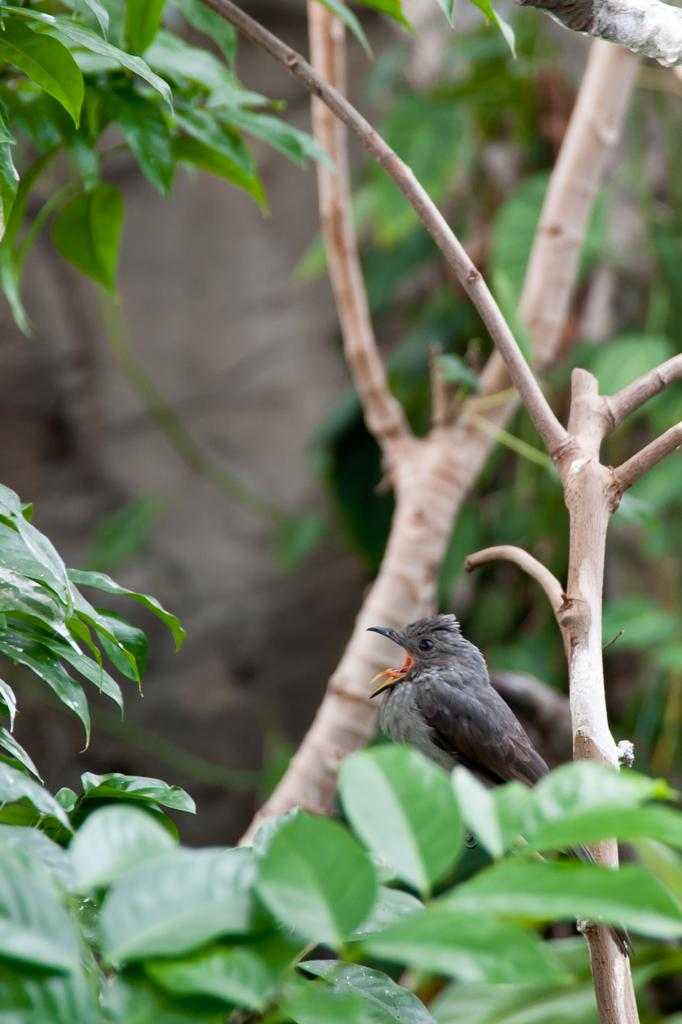What type of animal is in the image? There is a bird in the image. Where is the bird located? The bird is on a tree. Can you describe the background of the image? The background of the image is blurred. What type of tray is the bird carrying in the image? There is no tray present in the image; the bird is simply perched on a tree. 